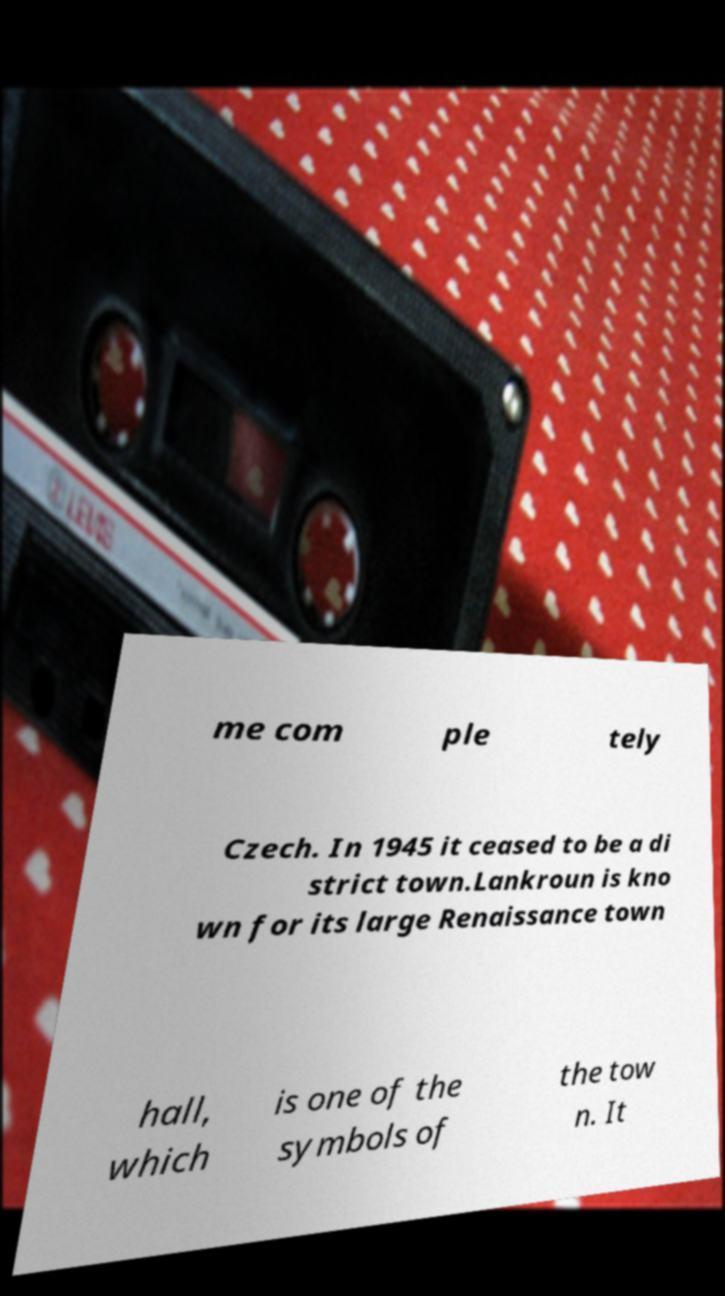For documentation purposes, I need the text within this image transcribed. Could you provide that? me com ple tely Czech. In 1945 it ceased to be a di strict town.Lankroun is kno wn for its large Renaissance town hall, which is one of the symbols of the tow n. It 